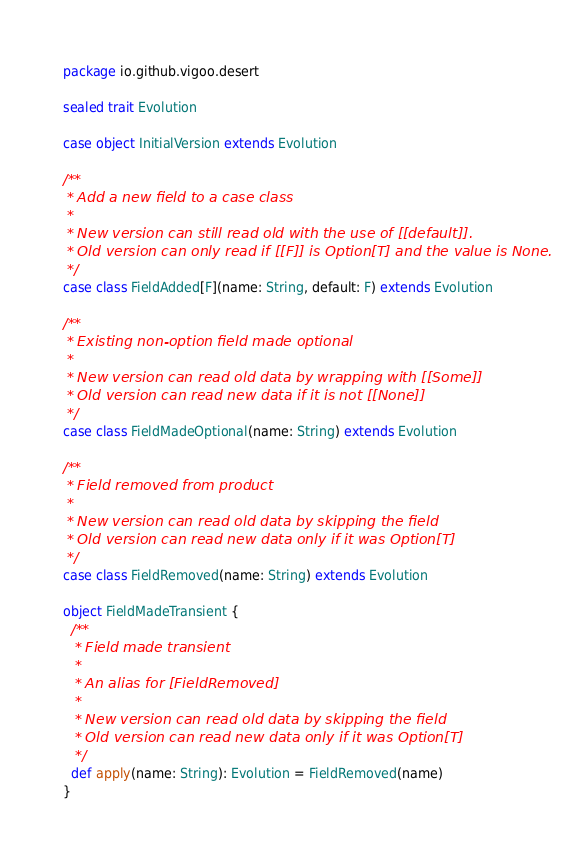Convert code to text. <code><loc_0><loc_0><loc_500><loc_500><_Scala_>package io.github.vigoo.desert

sealed trait Evolution

case object InitialVersion extends Evolution

/**
 * Add a new field to a case class
 *
 * New version can still read old with the use of [[default]].
 * Old version can only read if [[F]] is Option[T] and the value is None.
 */
case class FieldAdded[F](name: String, default: F) extends Evolution

/**
 * Existing non-option field made optional
 *
 * New version can read old data by wrapping with [[Some]]
 * Old version can read new data if it is not [[None]]
 */
case class FieldMadeOptional(name: String) extends Evolution

/**
 * Field removed from product
 *
 * New version can read old data by skipping the field
 * Old version can read new data only if it was Option[T]
 */
case class FieldRemoved(name: String) extends Evolution

object FieldMadeTransient {
  /**
   * Field made transient
   *
   * An alias for [FieldRemoved]
   *
   * New version can read old data by skipping the field
   * Old version can read new data only if it was Option[T]
   */
  def apply(name: String): Evolution = FieldRemoved(name)
}</code> 